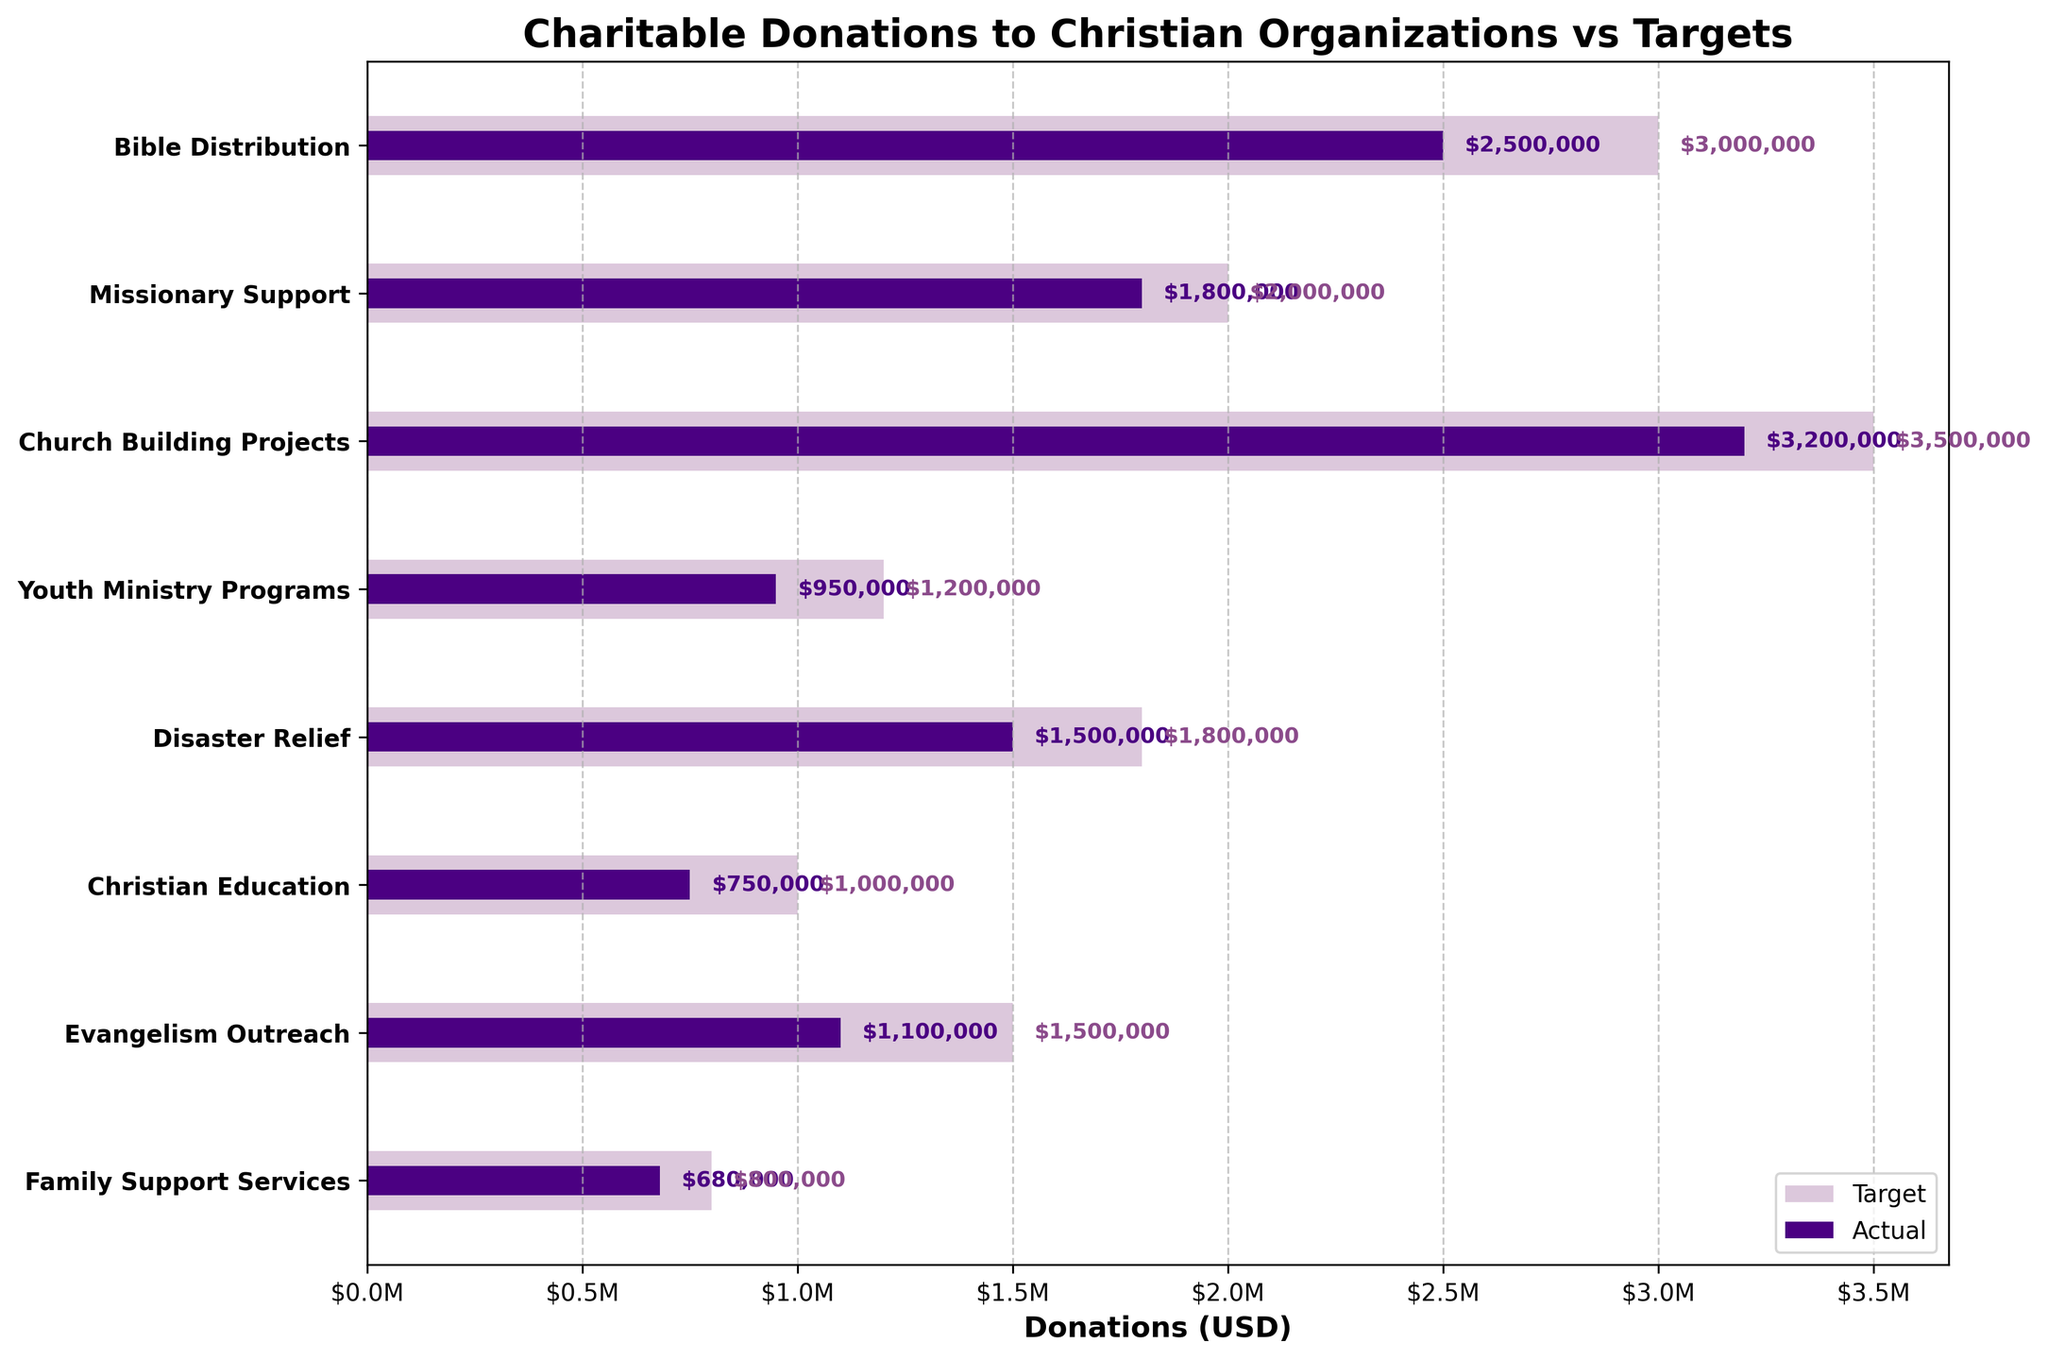What is the title of the chart? The title is located at the top of the chart and is often the largest and boldest text. This chart's title states the overall theme of the data.
Answer: Charitable Donations to Christian Organizations vs Targets What category has the highest target amount? Look for the longest bar in the background, which represents the target amounts for different categories.
Answer: Church Building Projects Which category has met its target the most closely based on actual donations? Compare the lengths of the actual and target bars. The category where the actual bar is closest in length to the target bar has met its target the most closely.
Answer: Family Support Services What is the difference between the actual and target donations for Youth Ministry Programs? Identify the values for both actual and target donations, then subtract the actual from the target (1,200,000 - 950,000).
Answer: $250,000 Which category has the smallest actual donations? Look for the shortest bar in the foreground, which represents the actual donations.
Answer: Family Support Services What is the total amount of target donations across all categories? Sum the target values for all categories: 3,000,000 + 2,000,000 + 3,500,000 + 1,200,000 + 1,800,000 + 1,000,000 + 1,500,000 + 800,000.
Answer: $14,800,000 By how much do actual donations for Bible Distribution fall short of the target? Subtract the actual donation from the target donation for Bible Distribution (3,000,000 - 2,500,000).
Answer: $500,000 Compare the actual donations of Missionary Support with Evangelism Outreach. Which is greater? Look at the lengths of the actual bars for Missionary Support and Evangelism Outreach, and identify which bar is longer.
Answer: Missionary Support If the total target donations were reduced by 10%, what would be the new total? Calculate 10% reduction of the total target donations (10% of 14,800,000), then subtract this value from the total (14,800,000 - 1,480,000).
Answer: $13,320,000 Which category has received actual donations that are less than half of its target? Look for categories where the actual donation bars are less than half the length of their respective target bars. Check if the actual value is less than half of the target value.
Answer: Christian Education 